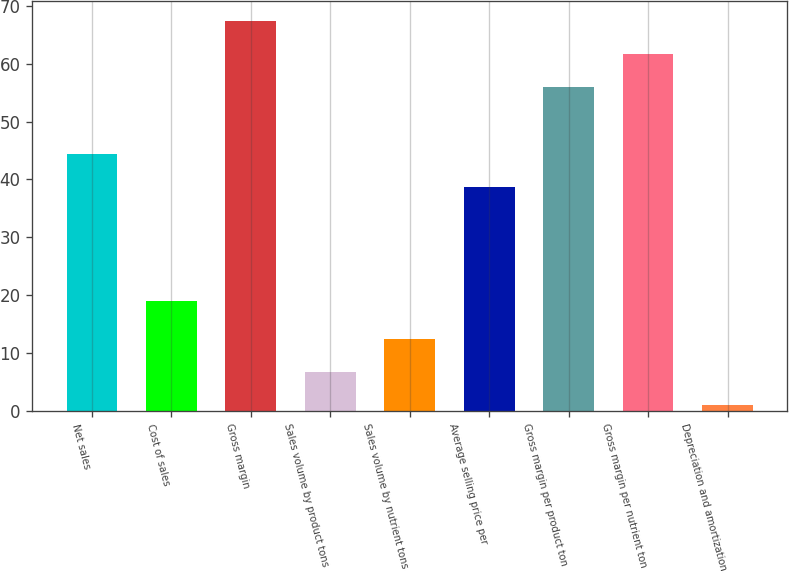<chart> <loc_0><loc_0><loc_500><loc_500><bar_chart><fcel>Net sales<fcel>Cost of sales<fcel>Gross margin<fcel>Sales volume by product tons<fcel>Sales volume by nutrient tons<fcel>Average selling price per<fcel>Gross margin per product ton<fcel>Gross margin per nutrient ton<fcel>Depreciation and amortization<nl><fcel>44.4<fcel>19<fcel>67.4<fcel>6.7<fcel>12.4<fcel>38.7<fcel>56<fcel>61.7<fcel>1<nl></chart> 